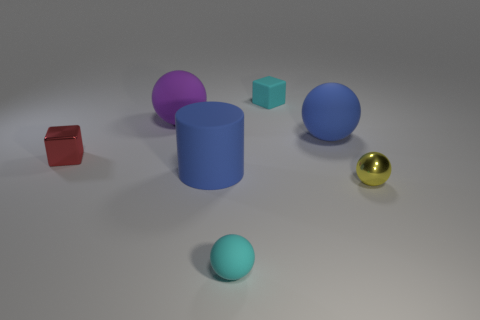Subtract all gray balls. Subtract all red cylinders. How many balls are left? 4 Add 2 matte cylinders. How many objects exist? 9 Subtract all spheres. How many objects are left? 3 Add 3 big purple rubber spheres. How many big purple rubber spheres exist? 4 Subtract 0 red spheres. How many objects are left? 7 Subtract all blue cylinders. Subtract all large green matte spheres. How many objects are left? 6 Add 1 matte cubes. How many matte cubes are left? 2 